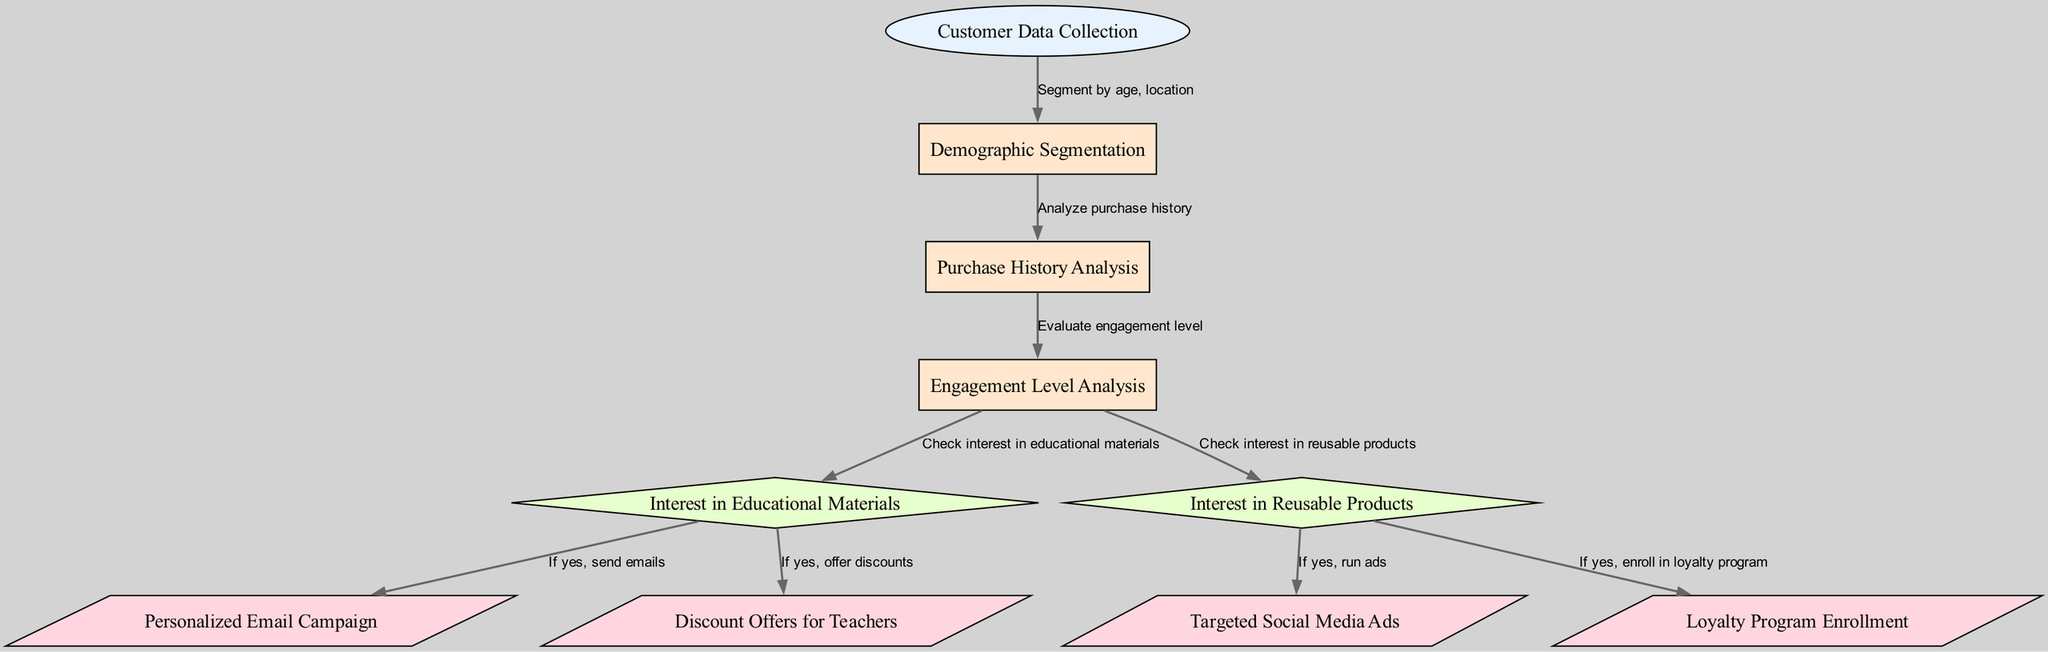What is the first step in the diagram? The first step is "Customer Data Collection" which is the initial node of the flow, indicating that it gathers relevant customer data before any processing occurs.
Answer: Customer Data Collection How many output nodes are present in the diagram? The diagram has four output nodes: "Personalized Email Campaign," "Targeted Social Media Ads," "Discount Offers for Teachers," and "Loyalty Program Enrollment," which are the final actions taken after analyzing customer data.
Answer: 4 What does the edge from "engagementLevelAnalysis" to "interestInEducationalMaterials" represent? The edge signifies a decision point where the flow checks for the customer's interest in educational materials based on their analyzed engagement level, leading to different marketing actions if the answer is yes.
Answer: Check interest in educational materials Which process node comes after "demographicSegmentation"? The process node following "demographicSegmentation" is "Purchase History Analysis," indicating that once demographic data is segmented, the next step is to analyze the customer's previous purchases.
Answer: Purchase History Analysis If a customer shows interest in reusable products, which output actions are possible? If interest in reusable products is confirmed, the diagram indicates two possible actions; they can receive "Targeted Social Media Ads" and their enrollment in the "Loyalty Program." Thus, each interest leads to specific marketing outputs.
Answer: Targeted Social Media Ads, Loyalty Program Enrollment What is checked after evaluating engagement levels? After evaluating engagement levels, the diagram checks for customer interest in both educational materials and reusable products, as both are critical factors in personalizing marketing strategies based on engagement.
Answer: Interest in Educational Materials, Interest in Reusable Products What is the purpose of the "Customer Data Collection" node? The "Customer Data Collection" node is designed to gather various customer data dimensions, including demographics and purchase behavior, which serve as the foundation for further analysis and segmentation in the marketing strategy.
Answer: Gather customer data Who receives discount offers based on the analysis in this diagram? "Discount Offers for Teachers" is the specific output directed toward teachers identified in the analysis stages of the flow, aimed to encourage their engagement and purchases of eco-friendly materials.
Answer: Teachers 